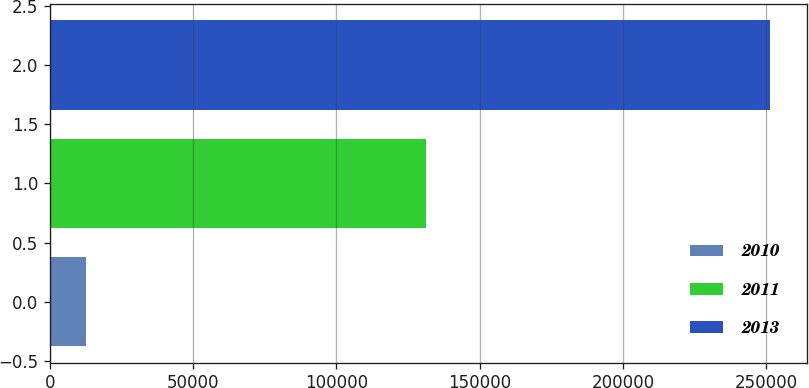Convert chart. <chart><loc_0><loc_0><loc_500><loc_500><bar_chart><fcel>2010<fcel>2011<fcel>2013<nl><fcel>12710<fcel>131352<fcel>251421<nl></chart> 